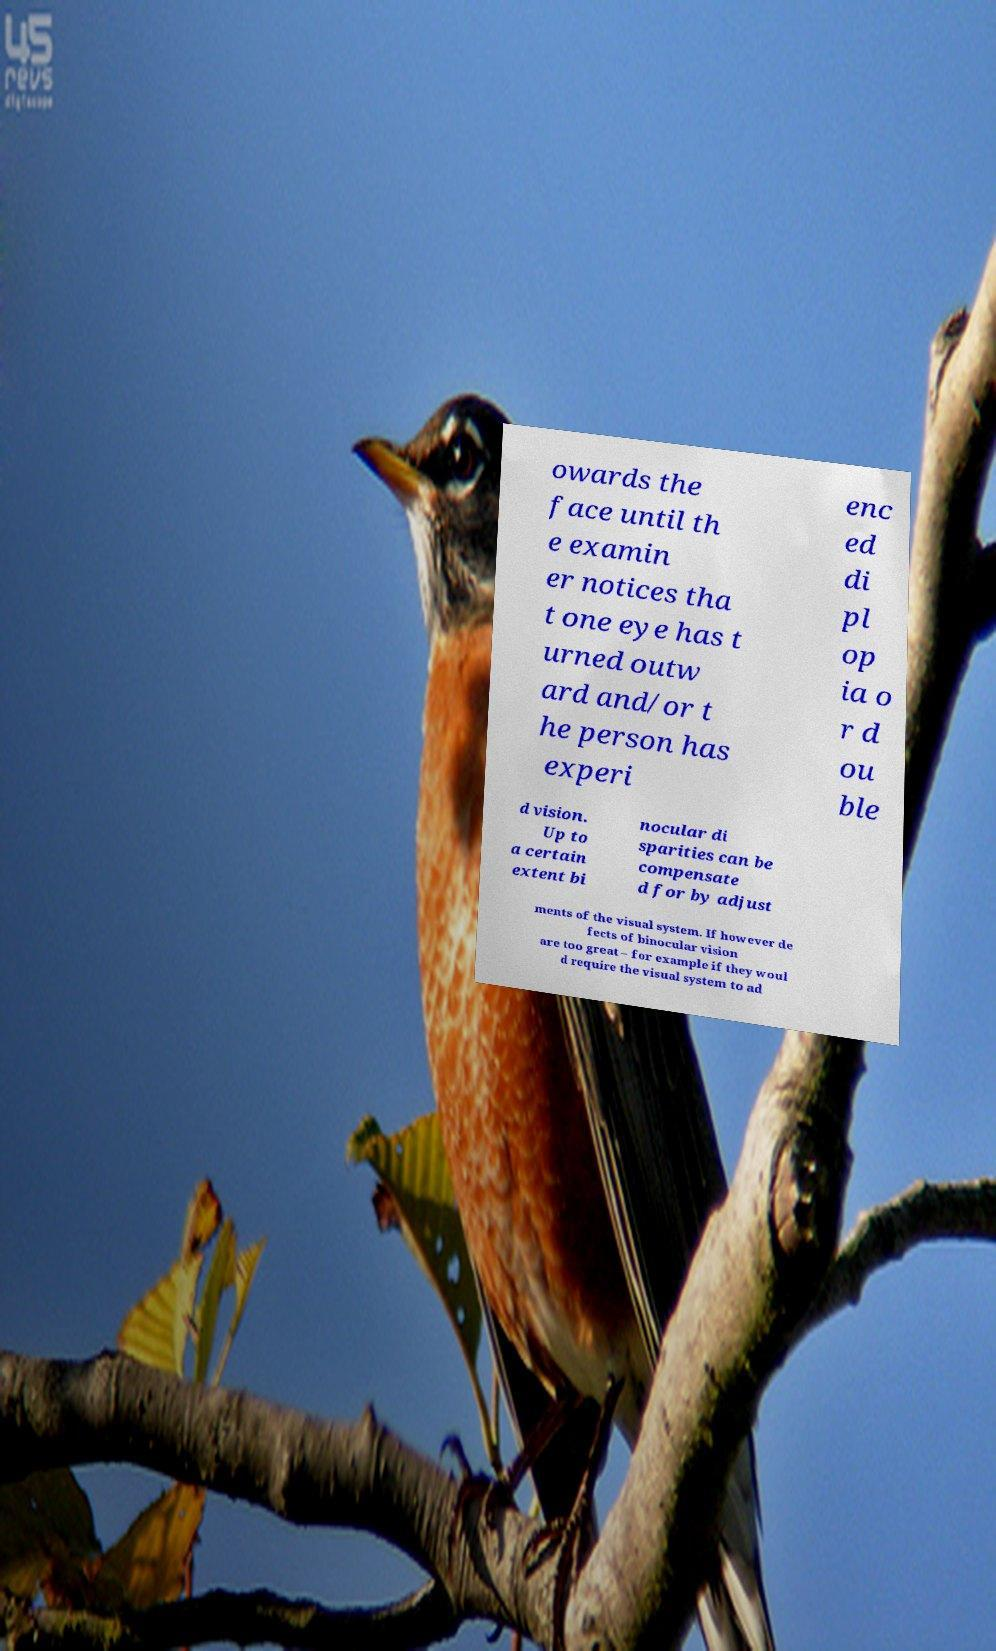Could you extract and type out the text from this image? owards the face until th e examin er notices tha t one eye has t urned outw ard and/or t he person has experi enc ed di pl op ia o r d ou ble d vision. Up to a certain extent bi nocular di sparities can be compensate d for by adjust ments of the visual system. If however de fects of binocular vision are too great – for example if they woul d require the visual system to ad 